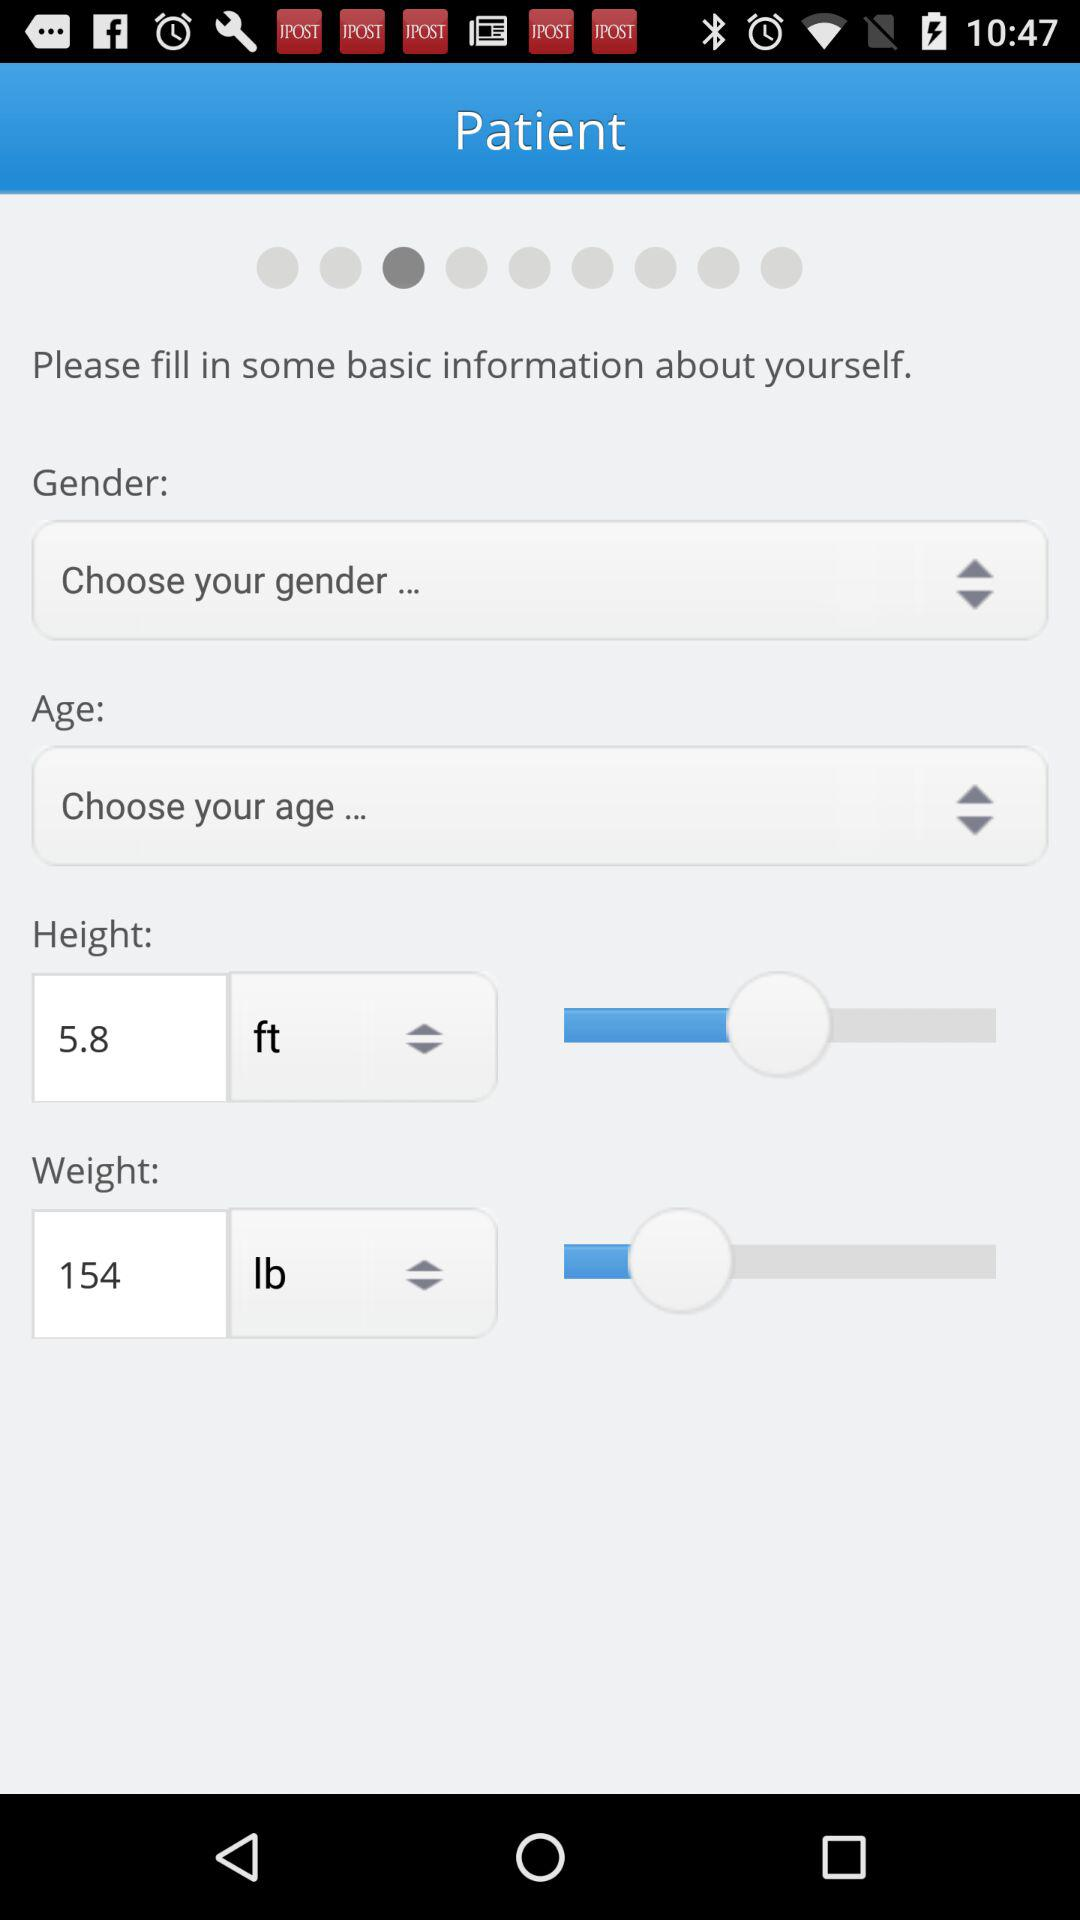What is the patient weight? The patient weight is 154 lbs. 